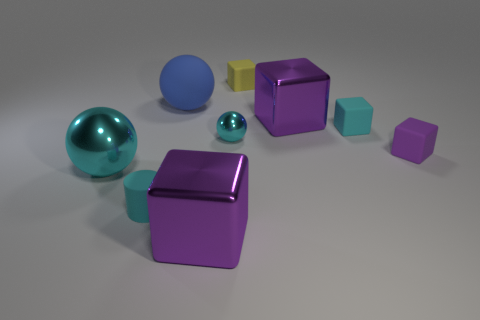What materials do the objects in the image appear to be made of? The objects in the image seem to be made of different materials. The two spheres have a glossy finish suggesting they might be made of a polished metal or plastic. The cubes have a matte finish, indicative of a rubbery material. The teal octahedron also has a matte surface and could be made of similar material as the cubes. 